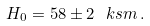<formula> <loc_0><loc_0><loc_500><loc_500>H _ { 0 } = 5 8 \pm 2 \ k s m \, .</formula> 